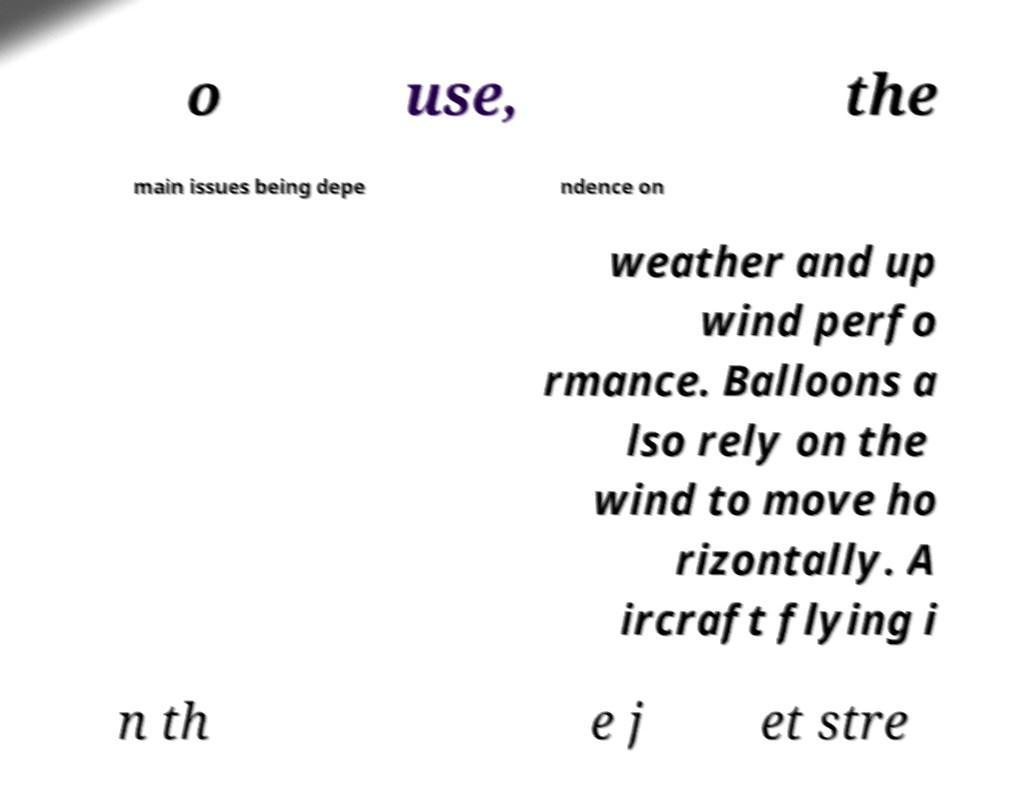Can you accurately transcribe the text from the provided image for me? o use, the main issues being depe ndence on weather and up wind perfo rmance. Balloons a lso rely on the wind to move ho rizontally. A ircraft flying i n th e j et stre 